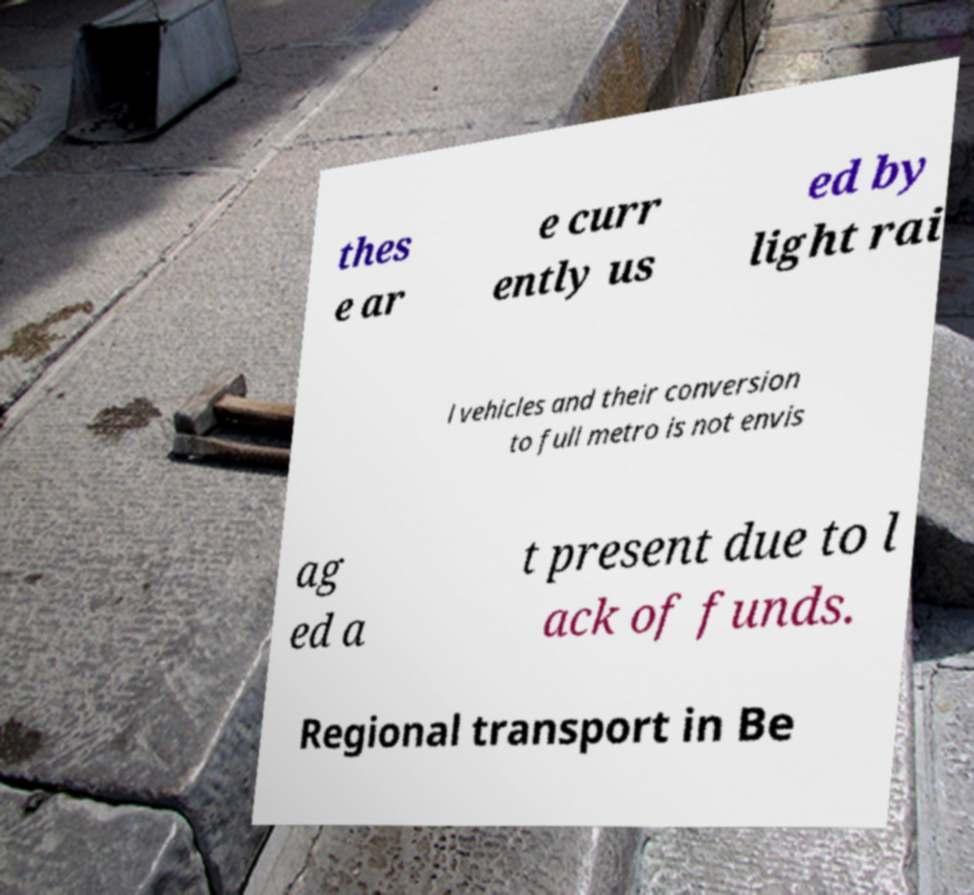Please identify and transcribe the text found in this image. thes e ar e curr ently us ed by light rai l vehicles and their conversion to full metro is not envis ag ed a t present due to l ack of funds. Regional transport in Be 